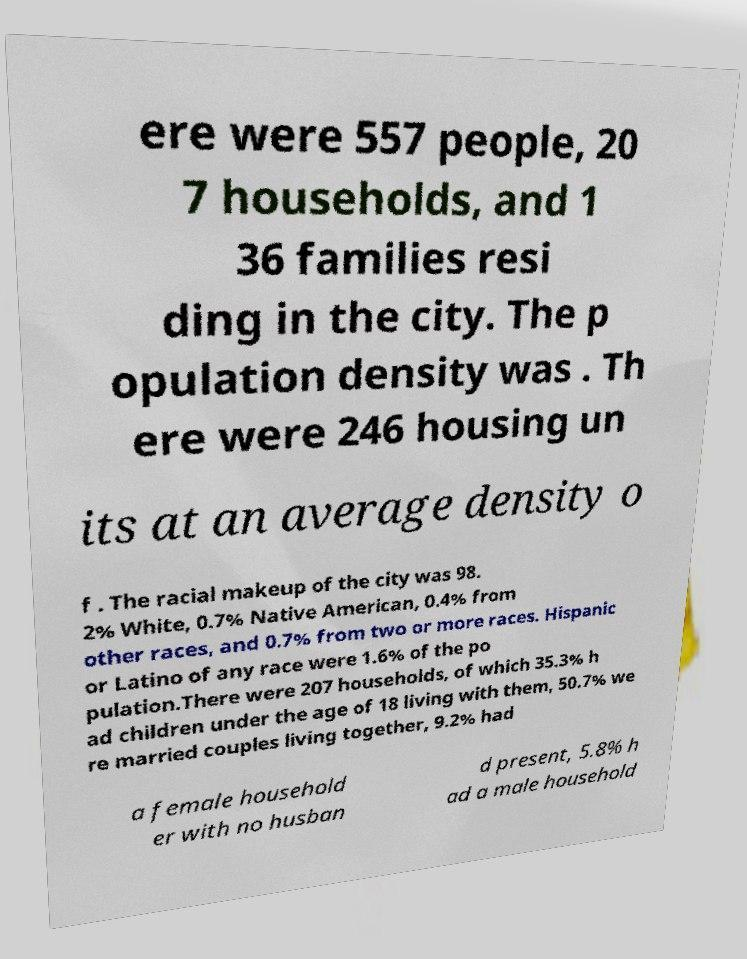Please read and relay the text visible in this image. What does it say? ere were 557 people, 20 7 households, and 1 36 families resi ding in the city. The p opulation density was . Th ere were 246 housing un its at an average density o f . The racial makeup of the city was 98. 2% White, 0.7% Native American, 0.4% from other races, and 0.7% from two or more races. Hispanic or Latino of any race were 1.6% of the po pulation.There were 207 households, of which 35.3% h ad children under the age of 18 living with them, 50.7% we re married couples living together, 9.2% had a female household er with no husban d present, 5.8% h ad a male household 